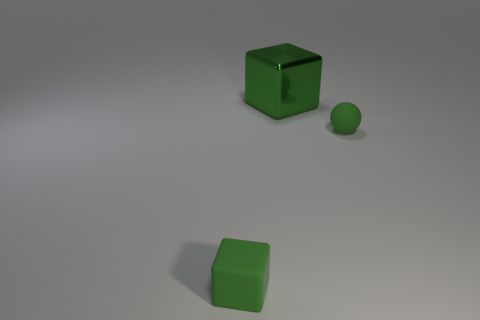There is a tiny cube; is its color the same as the tiny rubber thing that is behind the small matte block?
Give a very brief answer. Yes. What number of objects are either green metallic cubes or green things in front of the big metallic cube?
Ensure brevity in your answer.  3. Are there any other things that are the same material as the large object?
Offer a very short reply. No. There is a thing that is left of the ball and on the right side of the rubber cube; what material is it made of?
Provide a succinct answer. Metal. What number of other tiny yellow things are the same shape as the metal object?
Provide a succinct answer. 0. What color is the small ball behind the tiny object in front of the sphere?
Offer a very short reply. Green. Are there the same number of green shiny cubes that are to the left of the tiny green rubber cube and tiny purple metallic spheres?
Ensure brevity in your answer.  Yes. Are there any objects that have the same size as the rubber sphere?
Provide a succinct answer. Yes. Does the matte sphere have the same size as the matte object that is to the left of the green metallic cube?
Offer a terse response. Yes. Are there the same number of small green rubber blocks on the right side of the green ball and green rubber objects that are behind the matte cube?
Offer a very short reply. No. 